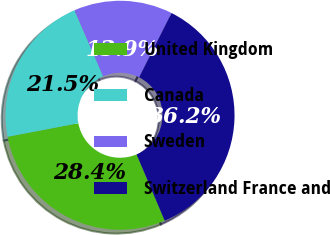Convert chart. <chart><loc_0><loc_0><loc_500><loc_500><pie_chart><fcel>United Kingdom<fcel>Canada<fcel>Sweden<fcel>Switzerland France and<nl><fcel>28.38%<fcel>21.49%<fcel>13.94%<fcel>36.19%<nl></chart> 